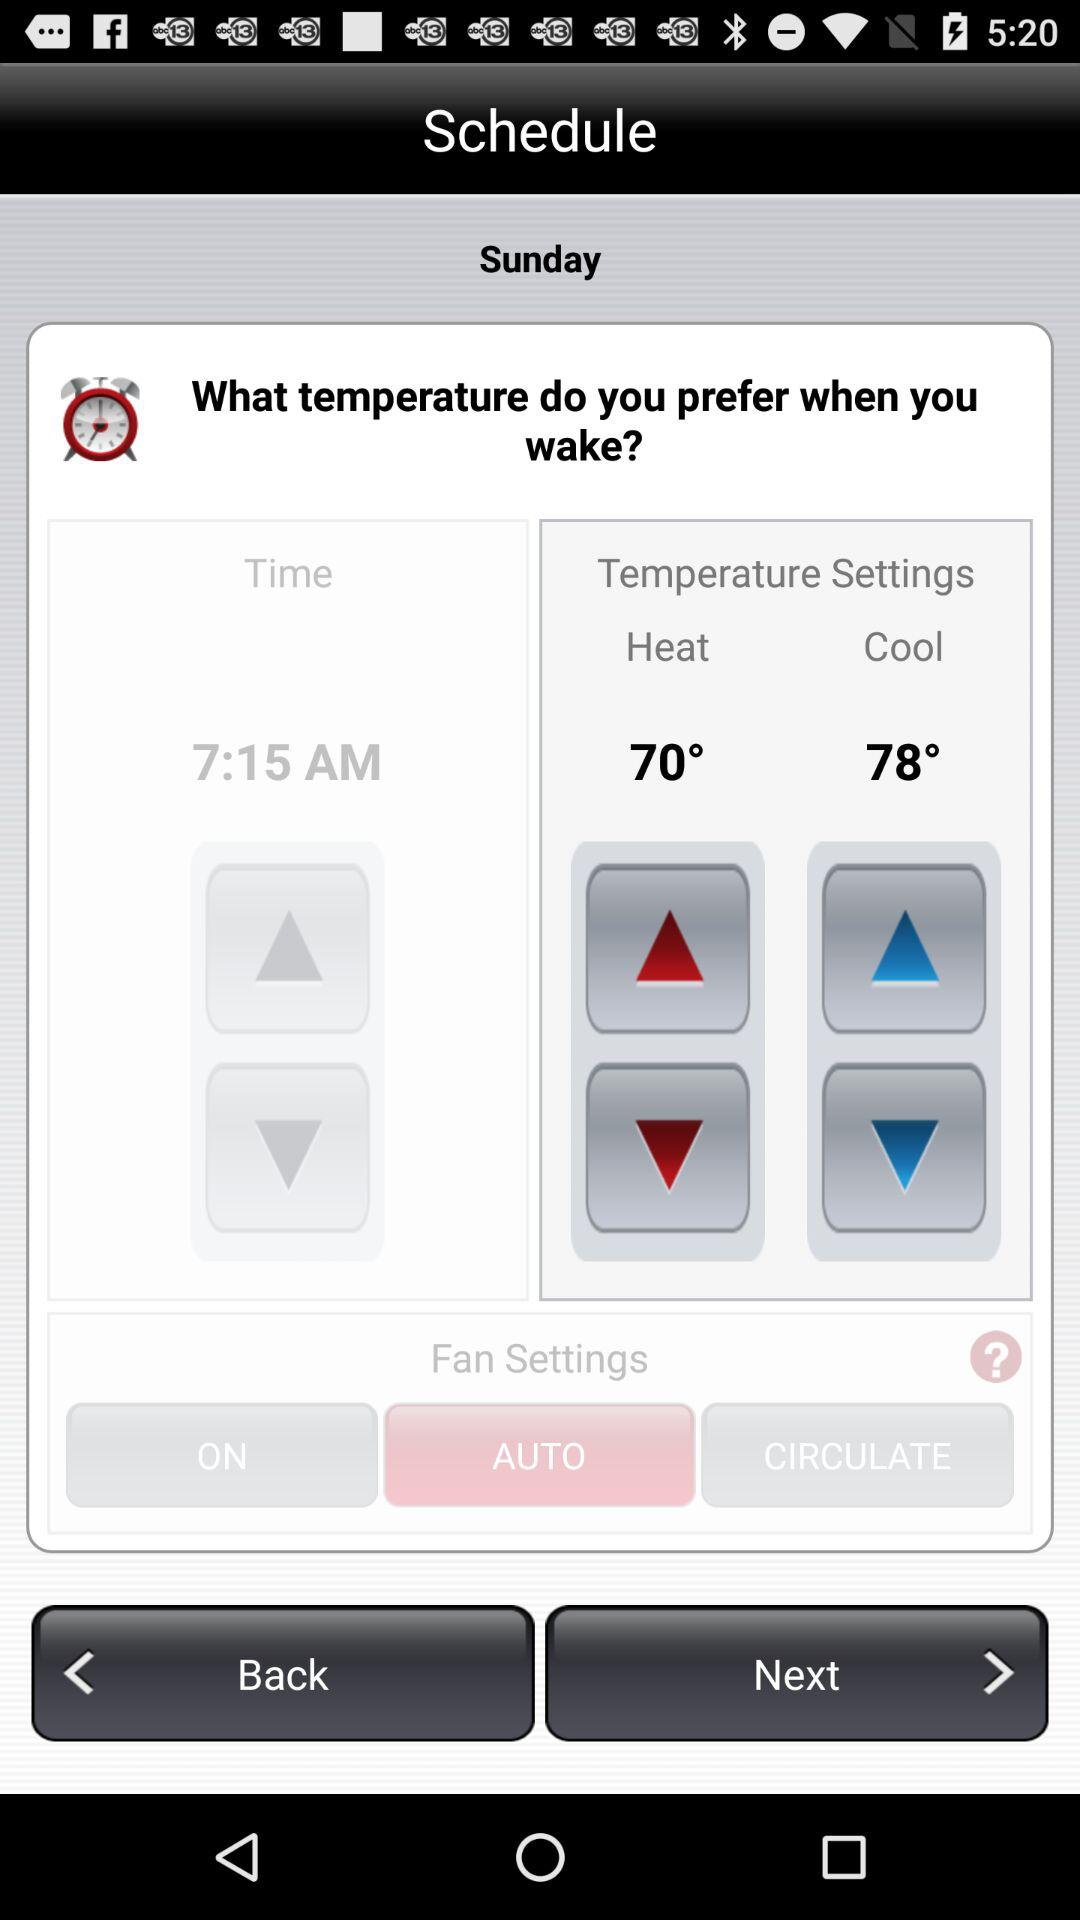How many temperature options are available?
Answer the question using a single word or phrase. 2 